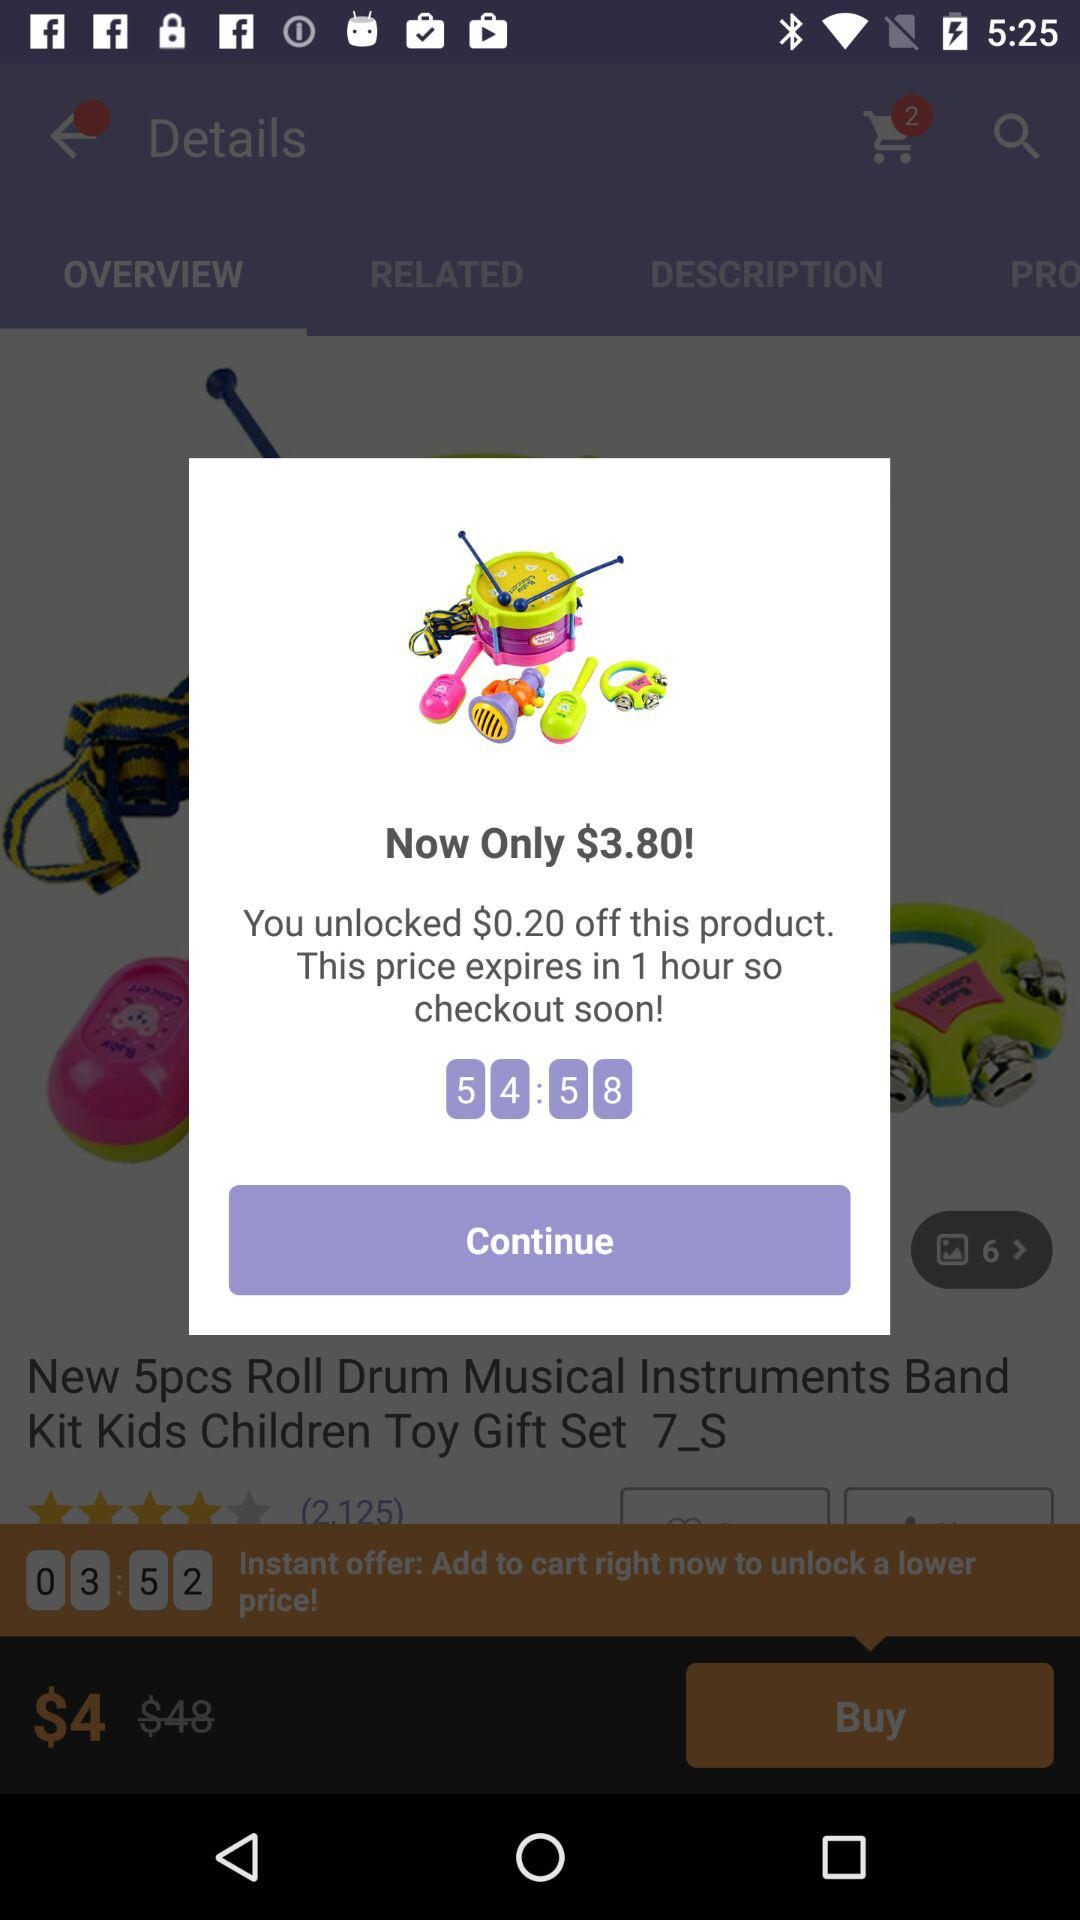How much money will I save if I buy the product now?
Answer the question using a single word or phrase. $0.20 